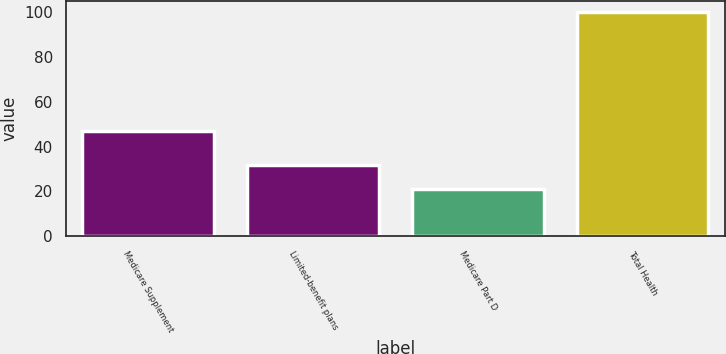Convert chart to OTSL. <chart><loc_0><loc_0><loc_500><loc_500><bar_chart><fcel>Medicare Supplement<fcel>Limited-benefit plans<fcel>Medicare Part D<fcel>Total Health<nl><fcel>47<fcel>32<fcel>21<fcel>100<nl></chart> 